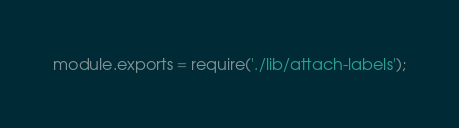Convert code to text. <code><loc_0><loc_0><loc_500><loc_500><_JavaScript_>module.exports = require('./lib/attach-labels');
</code> 